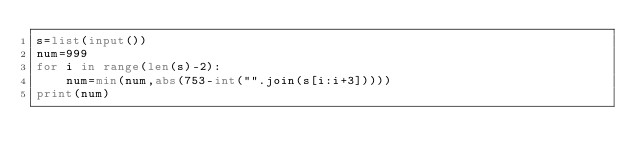<code> <loc_0><loc_0><loc_500><loc_500><_Python_>s=list(input())
num=999
for i in range(len(s)-2):
    num=min(num,abs(753-int("".join(s[i:i+3]))))
print(num)</code> 